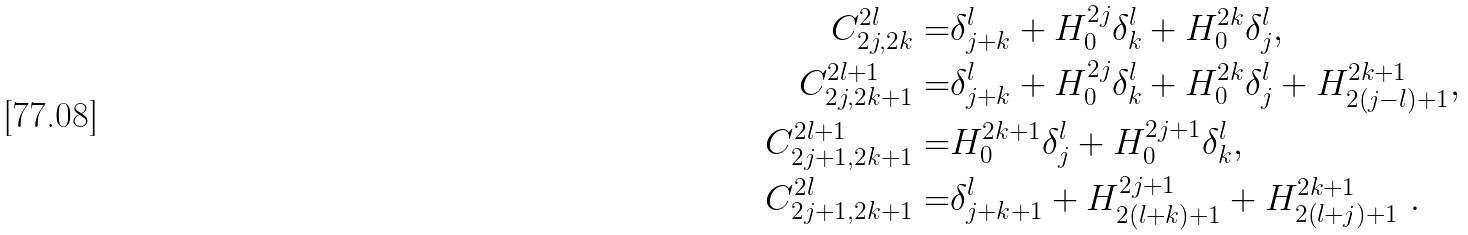<formula> <loc_0><loc_0><loc_500><loc_500>C ^ { 2 l } _ { 2 j , 2 k } = & \delta ^ { l } _ { j + k } + H ^ { 2 j } _ { 0 } \delta ^ { l } _ { k } + H ^ { 2 k } _ { 0 } \delta ^ { l } _ { j } , \\ C ^ { 2 l + 1 } _ { 2 j , 2 k + 1 } = & \delta ^ { l } _ { j + k } + H ^ { 2 j } _ { 0 } \delta ^ { l } _ { k } + H ^ { 2 k } _ { 0 } \delta ^ { l } _ { j } + H ^ { 2 k + 1 } _ { 2 ( j - l ) + 1 } , \\ C ^ { 2 l + 1 } _ { 2 j + 1 , 2 k + 1 } = & H ^ { 2 k + 1 } _ { 0 } \delta ^ { l } _ { j } + H ^ { 2 j + 1 } _ { 0 } \delta ^ { l } _ { k } , \\ C ^ { 2 l } _ { 2 j + 1 , 2 k + 1 } = & \delta ^ { l } _ { j + k + 1 } + H ^ { 2 j + 1 } _ { 2 ( l + k ) + 1 } + H ^ { 2 k + 1 } _ { 2 ( l + j ) + 1 } \ .</formula> 